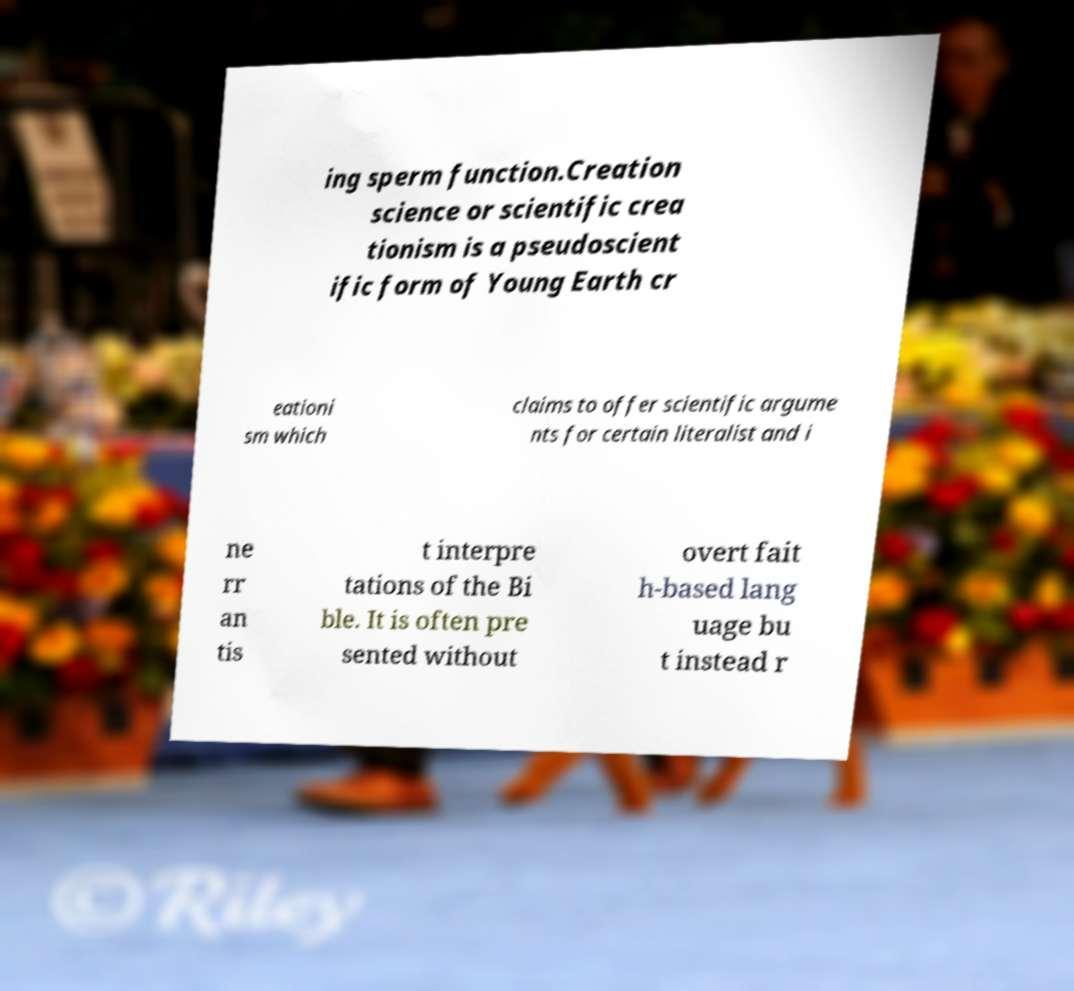Please identify and transcribe the text found in this image. ing sperm function.Creation science or scientific crea tionism is a pseudoscient ific form of Young Earth cr eationi sm which claims to offer scientific argume nts for certain literalist and i ne rr an tis t interpre tations of the Bi ble. It is often pre sented without overt fait h-based lang uage bu t instead r 